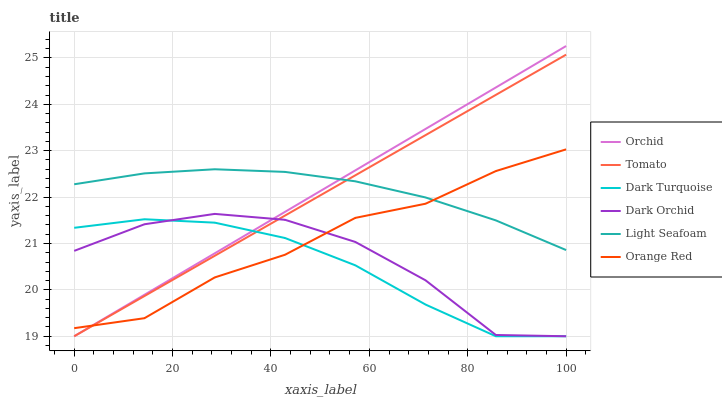Does Dark Turquoise have the minimum area under the curve?
Answer yes or no. Yes. Does Light Seafoam have the maximum area under the curve?
Answer yes or no. Yes. Does Dark Orchid have the minimum area under the curve?
Answer yes or no. No. Does Dark Orchid have the maximum area under the curve?
Answer yes or no. No. Is Tomato the smoothest?
Answer yes or no. Yes. Is Dark Orchid the roughest?
Answer yes or no. Yes. Is Dark Turquoise the smoothest?
Answer yes or no. No. Is Dark Turquoise the roughest?
Answer yes or no. No. Does Light Seafoam have the lowest value?
Answer yes or no. No. Does Orchid have the highest value?
Answer yes or no. Yes. Does Dark Orchid have the highest value?
Answer yes or no. No. Is Dark Orchid less than Light Seafoam?
Answer yes or no. Yes. Is Light Seafoam greater than Dark Turquoise?
Answer yes or no. Yes. Does Tomato intersect Dark Turquoise?
Answer yes or no. Yes. Is Tomato less than Dark Turquoise?
Answer yes or no. No. Is Tomato greater than Dark Turquoise?
Answer yes or no. No. Does Dark Orchid intersect Light Seafoam?
Answer yes or no. No. 